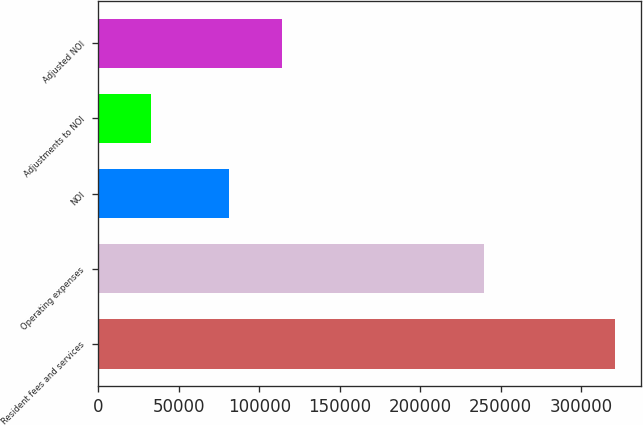Convert chart. <chart><loc_0><loc_0><loc_500><loc_500><bar_chart><fcel>Resident fees and services<fcel>Operating expenses<fcel>NOI<fcel>Adjustments to NOI<fcel>Adjusted NOI<nl><fcel>321209<fcel>239702<fcel>81507<fcel>32863<fcel>114370<nl></chart> 